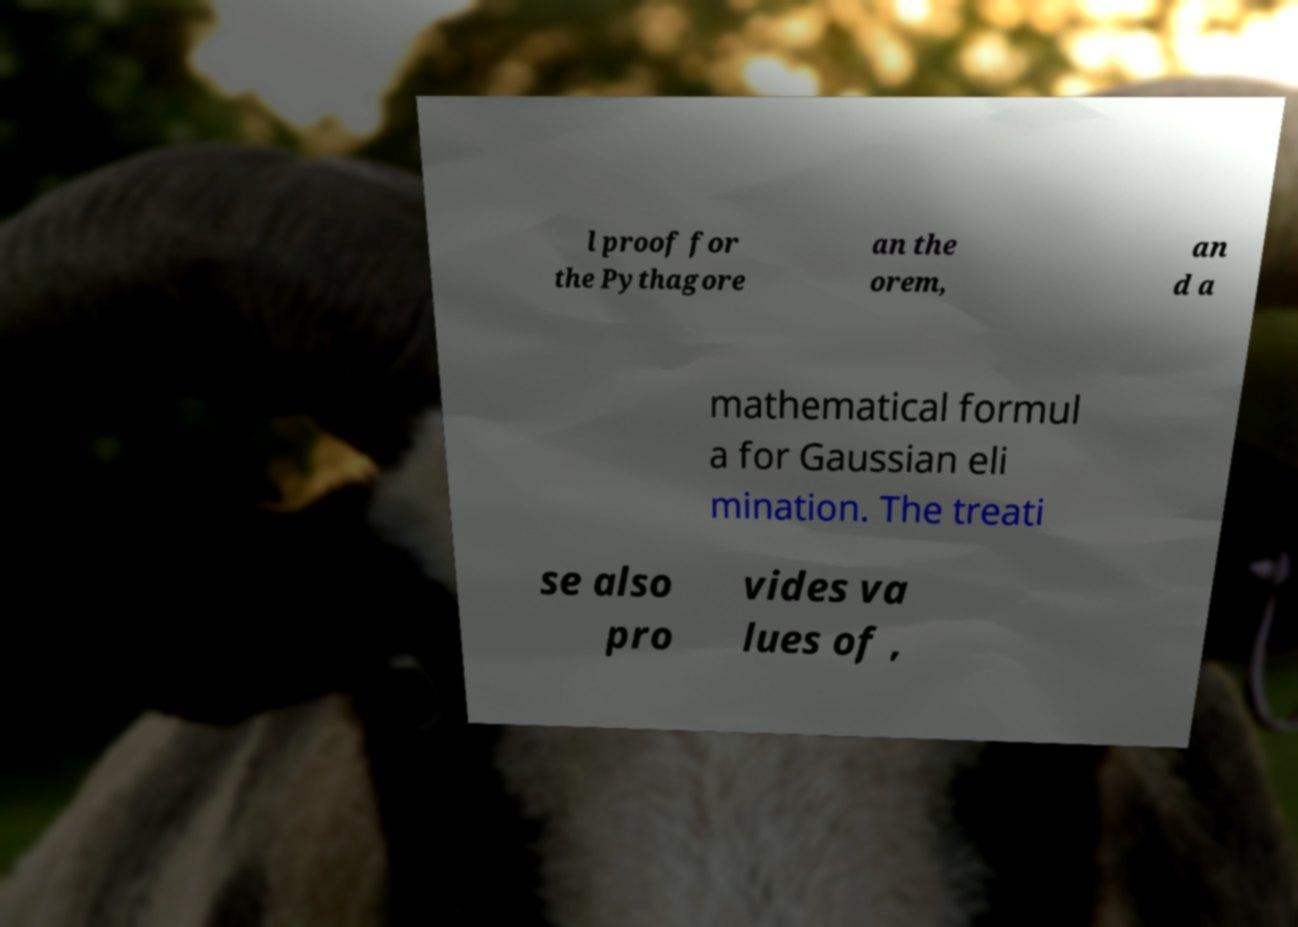Can you accurately transcribe the text from the provided image for me? l proof for the Pythagore an the orem, an d a mathematical formul a for Gaussian eli mination. The treati se also pro vides va lues of , 